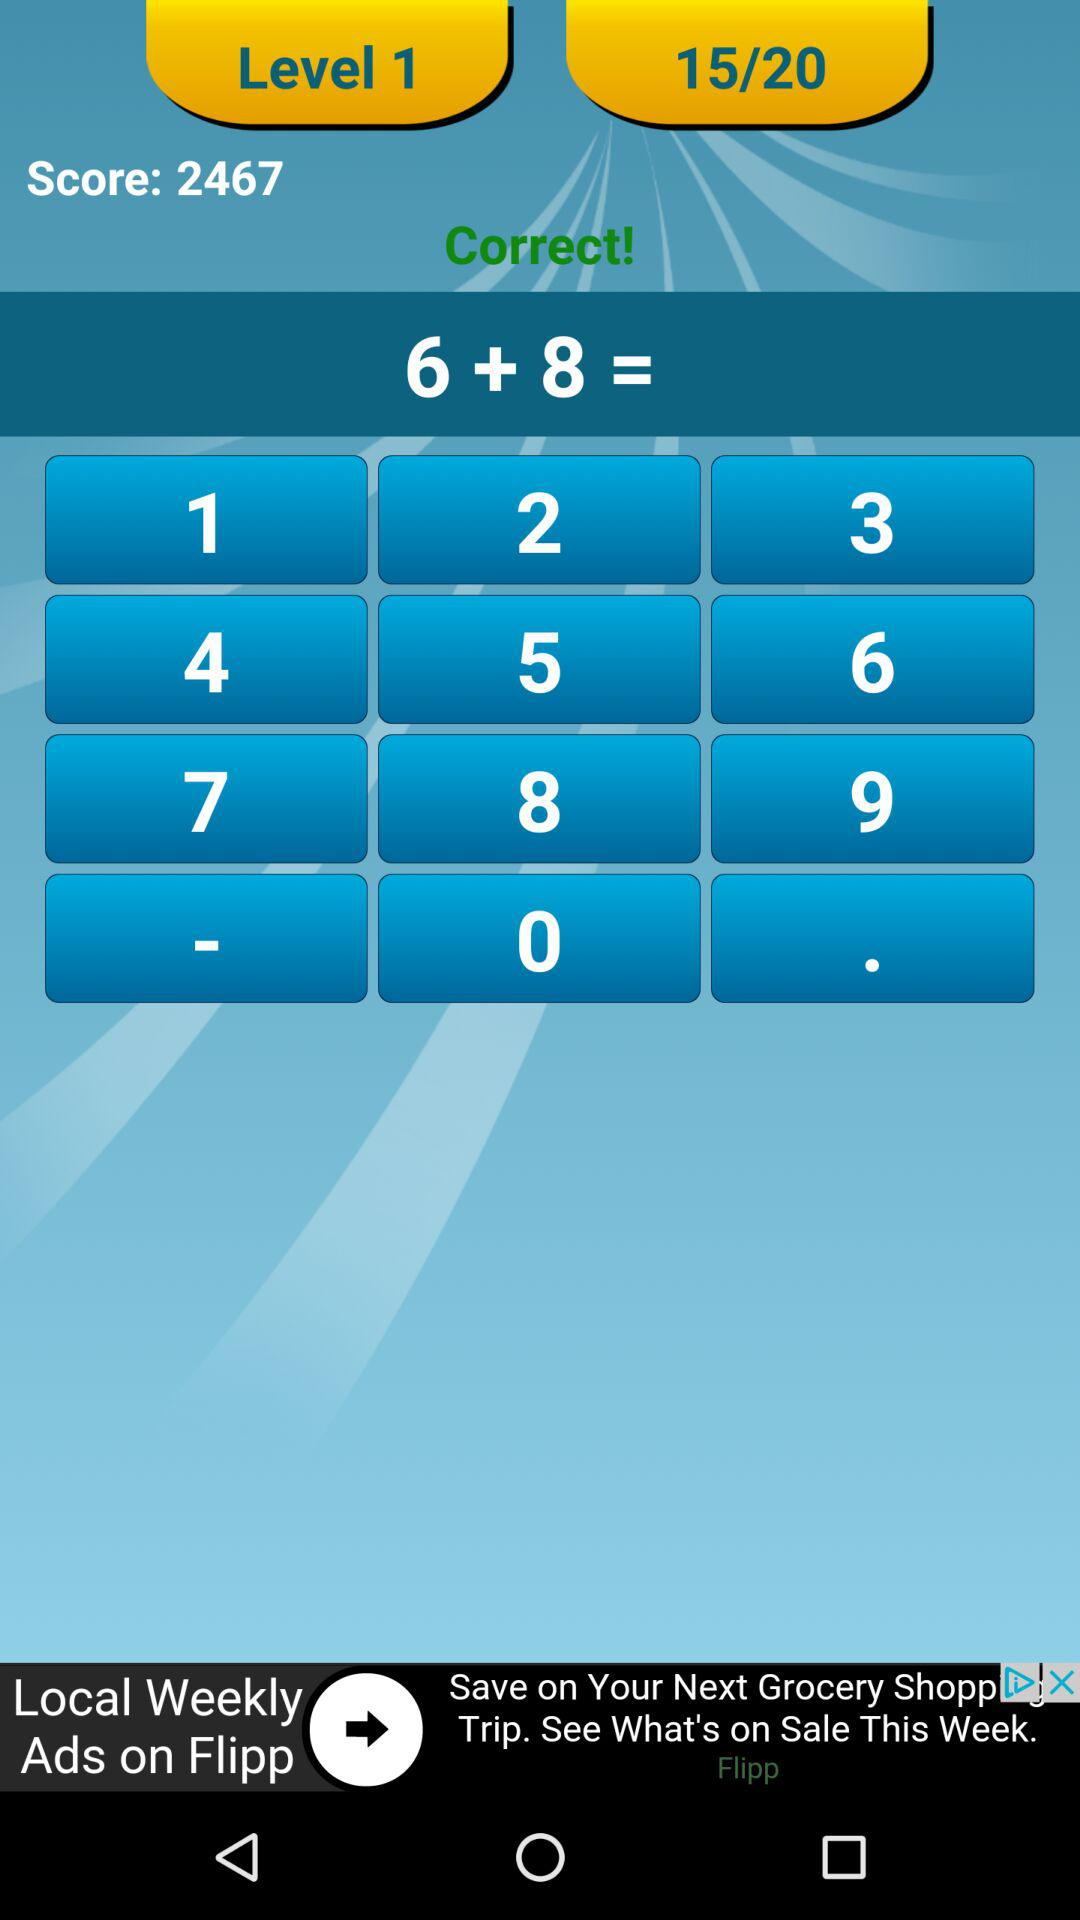What is the total number of questions? The total number of questions is 20. 